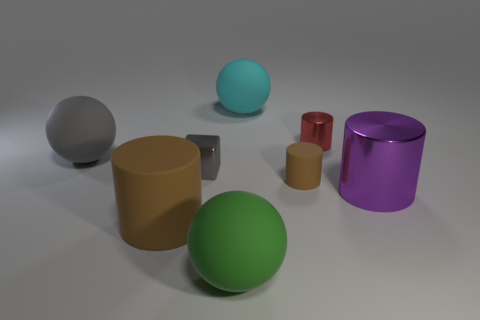Which objects in this image are spheres, and what are their colors? In the image, there are two spherical objects. One is a vibrant turquoise and the other is a soft green hue. 